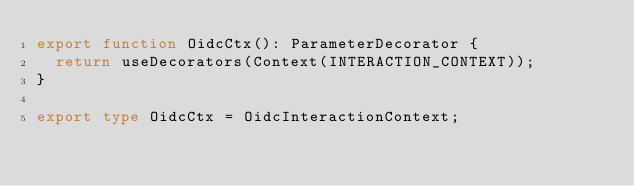Convert code to text. <code><loc_0><loc_0><loc_500><loc_500><_TypeScript_>export function OidcCtx(): ParameterDecorator {
  return useDecorators(Context(INTERACTION_CONTEXT));
}

export type OidcCtx = OidcInteractionContext;
</code> 